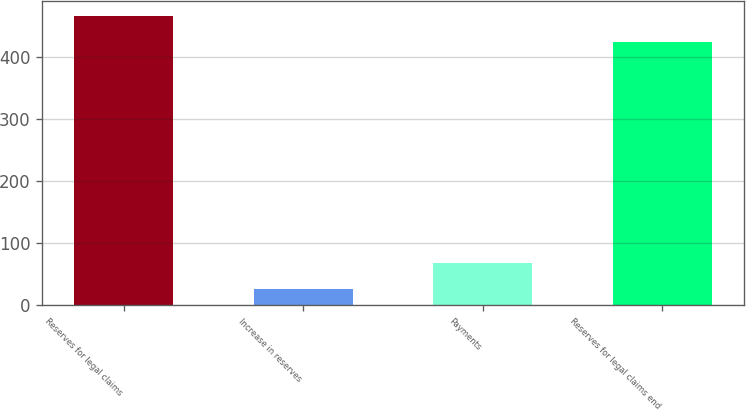<chart> <loc_0><loc_0><loc_500><loc_500><bar_chart><fcel>Reserves for legal claims<fcel>Increase in reserves<fcel>Payments<fcel>Reserves for legal claims end<nl><fcel>466.06<fcel>25.4<fcel>67.96<fcel>423.5<nl></chart> 